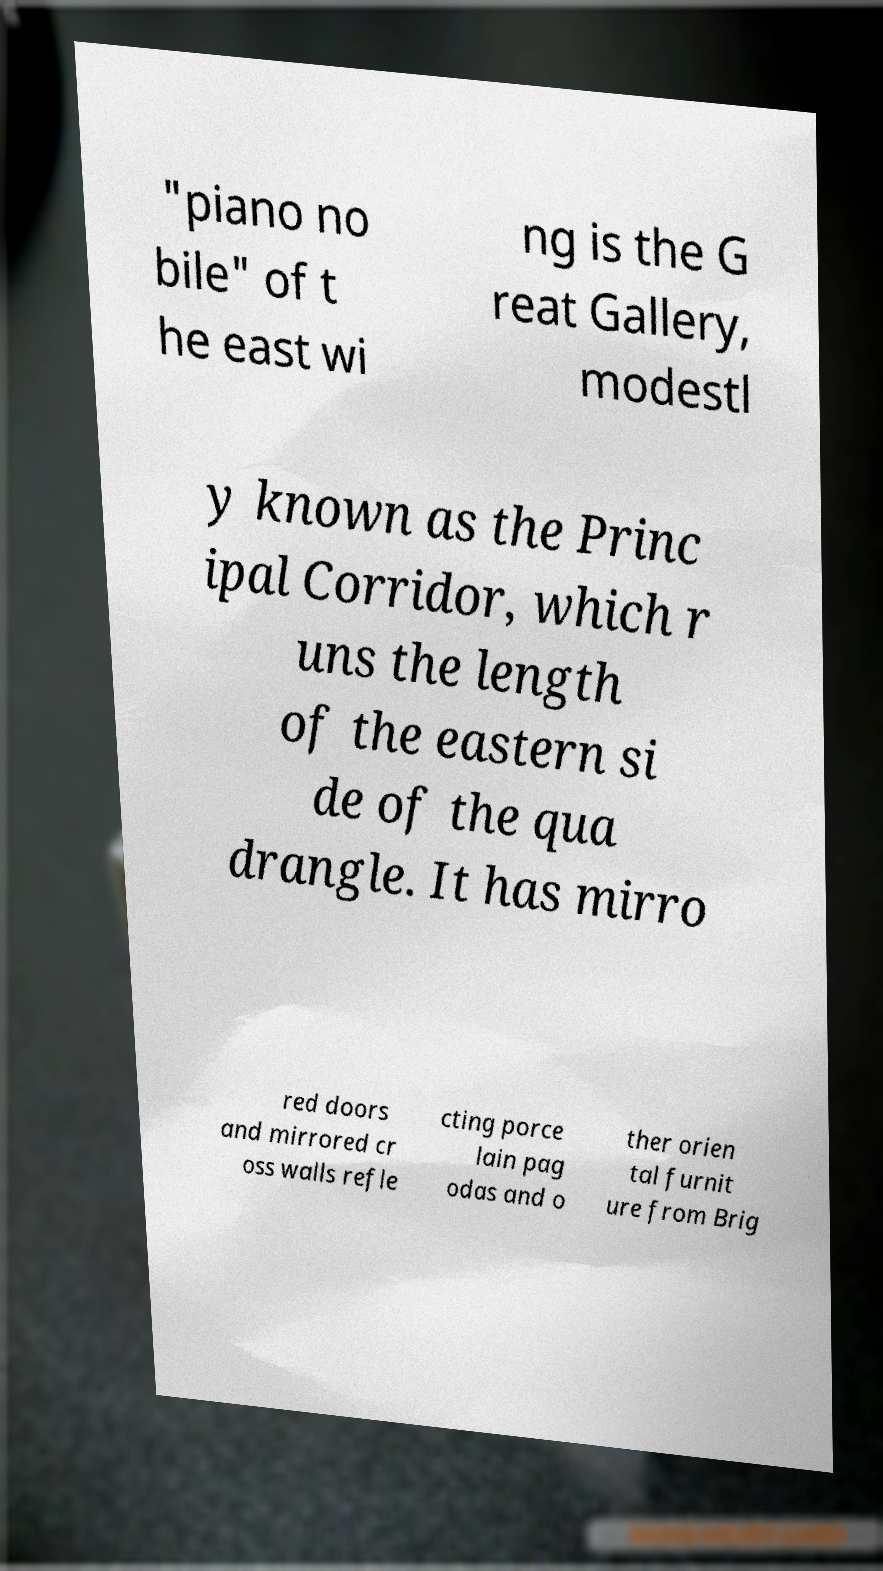Can you accurately transcribe the text from the provided image for me? "piano no bile" of t he east wi ng is the G reat Gallery, modestl y known as the Princ ipal Corridor, which r uns the length of the eastern si de of the qua drangle. It has mirro red doors and mirrored cr oss walls refle cting porce lain pag odas and o ther orien tal furnit ure from Brig 